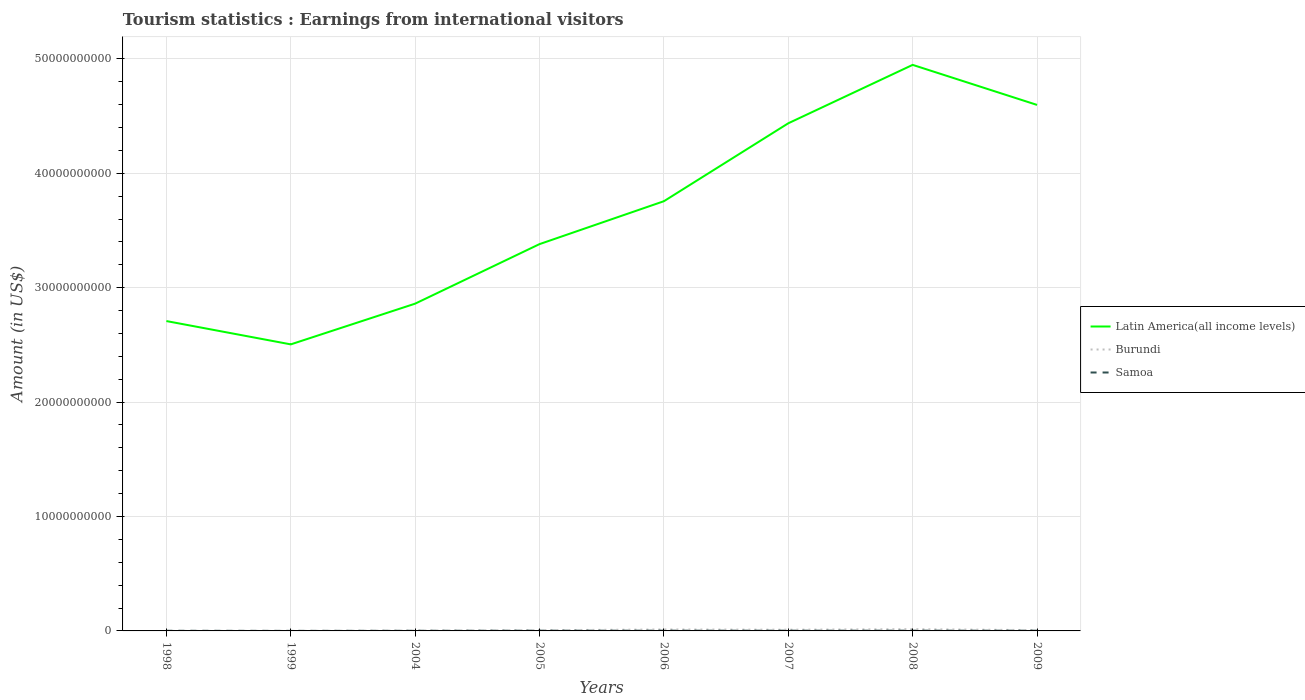Does the line corresponding to Burundi intersect with the line corresponding to Latin America(all income levels)?
Keep it short and to the point. No. Is the number of lines equal to the number of legend labels?
Give a very brief answer. Yes. Across all years, what is the maximum earnings from international visitors in Latin America(all income levels)?
Provide a succinct answer. 2.50e+1. In which year was the earnings from international visitors in Samoa maximum?
Your answer should be very brief. 1999. What is the total earnings from international visitors in Burundi in the graph?
Keep it short and to the point. -3.30e+07. What is the difference between the highest and the second highest earnings from international visitors in Burundi?
Offer a terse response. 1.49e+08. What is the difference between two consecutive major ticks on the Y-axis?
Your response must be concise. 1.00e+1. Are the values on the major ticks of Y-axis written in scientific E-notation?
Provide a short and direct response. No. What is the title of the graph?
Your response must be concise. Tourism statistics : Earnings from international visitors. Does "Uruguay" appear as one of the legend labels in the graph?
Offer a terse response. No. What is the label or title of the Y-axis?
Offer a terse response. Amount (in US$). What is the Amount (in US$) in Latin America(all income levels) in 1998?
Keep it short and to the point. 2.71e+1. What is the Amount (in US$) in Samoa in 1998?
Offer a terse response. 1.20e+07. What is the Amount (in US$) in Latin America(all income levels) in 1999?
Offer a very short reply. 2.50e+1. What is the Amount (in US$) in Samoa in 1999?
Your answer should be very brief. 4.40e+06. What is the Amount (in US$) in Latin America(all income levels) in 2004?
Your answer should be compact. 2.86e+1. What is the Amount (in US$) in Burundi in 2004?
Your response must be concise. 2.90e+07. What is the Amount (in US$) of Samoa in 2004?
Ensure brevity in your answer.  1.20e+07. What is the Amount (in US$) of Latin America(all income levels) in 2005?
Keep it short and to the point. 3.38e+1. What is the Amount (in US$) in Burundi in 2005?
Your answer should be very brief. 6.20e+07. What is the Amount (in US$) in Samoa in 2005?
Your answer should be compact. 2.03e+07. What is the Amount (in US$) in Latin America(all income levels) in 2006?
Your answer should be compact. 3.76e+1. What is the Amount (in US$) of Burundi in 2006?
Offer a terse response. 1.26e+08. What is the Amount (in US$) in Samoa in 2006?
Offer a very short reply. 2.12e+07. What is the Amount (in US$) of Latin America(all income levels) in 2007?
Your response must be concise. 4.44e+1. What is the Amount (in US$) of Burundi in 2007?
Provide a succinct answer. 1.06e+08. What is the Amount (in US$) in Samoa in 2007?
Keep it short and to the point. 1.98e+07. What is the Amount (in US$) of Latin America(all income levels) in 2008?
Keep it short and to the point. 4.95e+1. What is the Amount (in US$) of Burundi in 2008?
Your response must be concise. 1.51e+08. What is the Amount (in US$) of Samoa in 2008?
Your answer should be very brief. 2.16e+07. What is the Amount (in US$) of Latin America(all income levels) in 2009?
Keep it short and to the point. 4.60e+1. What is the Amount (in US$) in Burundi in 2009?
Your answer should be very brief. 7.10e+07. Across all years, what is the maximum Amount (in US$) in Latin America(all income levels)?
Your answer should be compact. 4.95e+1. Across all years, what is the maximum Amount (in US$) of Burundi?
Give a very brief answer. 1.51e+08. Across all years, what is the maximum Amount (in US$) of Samoa?
Your answer should be compact. 2.16e+07. Across all years, what is the minimum Amount (in US$) in Latin America(all income levels)?
Your answer should be very brief. 2.50e+1. Across all years, what is the minimum Amount (in US$) in Samoa?
Make the answer very short. 4.40e+06. What is the total Amount (in US$) of Latin America(all income levels) in the graph?
Your answer should be compact. 2.92e+11. What is the total Amount (in US$) in Burundi in the graph?
Keep it short and to the point. 5.50e+08. What is the total Amount (in US$) in Samoa in the graph?
Keep it short and to the point. 1.31e+08. What is the difference between the Amount (in US$) in Latin America(all income levels) in 1998 and that in 1999?
Offer a terse response. 2.04e+09. What is the difference between the Amount (in US$) of Samoa in 1998 and that in 1999?
Make the answer very short. 7.60e+06. What is the difference between the Amount (in US$) in Latin America(all income levels) in 1998 and that in 2004?
Provide a succinct answer. -1.52e+09. What is the difference between the Amount (in US$) of Burundi in 1998 and that in 2004?
Make the answer very short. -2.60e+07. What is the difference between the Amount (in US$) in Latin America(all income levels) in 1998 and that in 2005?
Your answer should be very brief. -6.73e+09. What is the difference between the Amount (in US$) in Burundi in 1998 and that in 2005?
Your answer should be compact. -5.90e+07. What is the difference between the Amount (in US$) in Samoa in 1998 and that in 2005?
Your answer should be very brief. -8.30e+06. What is the difference between the Amount (in US$) of Latin America(all income levels) in 1998 and that in 2006?
Give a very brief answer. -1.05e+1. What is the difference between the Amount (in US$) of Burundi in 1998 and that in 2006?
Provide a succinct answer. -1.23e+08. What is the difference between the Amount (in US$) of Samoa in 1998 and that in 2006?
Your response must be concise. -9.20e+06. What is the difference between the Amount (in US$) of Latin America(all income levels) in 1998 and that in 2007?
Your answer should be compact. -1.73e+1. What is the difference between the Amount (in US$) of Burundi in 1998 and that in 2007?
Your response must be concise. -1.03e+08. What is the difference between the Amount (in US$) of Samoa in 1998 and that in 2007?
Keep it short and to the point. -7.80e+06. What is the difference between the Amount (in US$) of Latin America(all income levels) in 1998 and that in 2008?
Make the answer very short. -2.24e+1. What is the difference between the Amount (in US$) in Burundi in 1998 and that in 2008?
Provide a short and direct response. -1.48e+08. What is the difference between the Amount (in US$) in Samoa in 1998 and that in 2008?
Your response must be concise. -9.60e+06. What is the difference between the Amount (in US$) of Latin America(all income levels) in 1998 and that in 2009?
Provide a short and direct response. -1.89e+1. What is the difference between the Amount (in US$) in Burundi in 1998 and that in 2009?
Your answer should be compact. -6.80e+07. What is the difference between the Amount (in US$) in Samoa in 1998 and that in 2009?
Make the answer very short. -8.00e+06. What is the difference between the Amount (in US$) of Latin America(all income levels) in 1999 and that in 2004?
Your response must be concise. -3.56e+09. What is the difference between the Amount (in US$) of Burundi in 1999 and that in 2004?
Your answer should be very brief. -2.70e+07. What is the difference between the Amount (in US$) in Samoa in 1999 and that in 2004?
Your response must be concise. -7.60e+06. What is the difference between the Amount (in US$) of Latin America(all income levels) in 1999 and that in 2005?
Ensure brevity in your answer.  -8.76e+09. What is the difference between the Amount (in US$) of Burundi in 1999 and that in 2005?
Your answer should be very brief. -6.00e+07. What is the difference between the Amount (in US$) in Samoa in 1999 and that in 2005?
Give a very brief answer. -1.59e+07. What is the difference between the Amount (in US$) in Latin America(all income levels) in 1999 and that in 2006?
Your response must be concise. -1.25e+1. What is the difference between the Amount (in US$) of Burundi in 1999 and that in 2006?
Provide a short and direct response. -1.24e+08. What is the difference between the Amount (in US$) in Samoa in 1999 and that in 2006?
Offer a very short reply. -1.68e+07. What is the difference between the Amount (in US$) in Latin America(all income levels) in 1999 and that in 2007?
Make the answer very short. -1.93e+1. What is the difference between the Amount (in US$) of Burundi in 1999 and that in 2007?
Ensure brevity in your answer.  -1.04e+08. What is the difference between the Amount (in US$) of Samoa in 1999 and that in 2007?
Keep it short and to the point. -1.54e+07. What is the difference between the Amount (in US$) in Latin America(all income levels) in 1999 and that in 2008?
Make the answer very short. -2.44e+1. What is the difference between the Amount (in US$) of Burundi in 1999 and that in 2008?
Offer a very short reply. -1.49e+08. What is the difference between the Amount (in US$) in Samoa in 1999 and that in 2008?
Give a very brief answer. -1.72e+07. What is the difference between the Amount (in US$) of Latin America(all income levels) in 1999 and that in 2009?
Keep it short and to the point. -2.09e+1. What is the difference between the Amount (in US$) in Burundi in 1999 and that in 2009?
Your answer should be compact. -6.90e+07. What is the difference between the Amount (in US$) in Samoa in 1999 and that in 2009?
Your response must be concise. -1.56e+07. What is the difference between the Amount (in US$) in Latin America(all income levels) in 2004 and that in 2005?
Make the answer very short. -5.20e+09. What is the difference between the Amount (in US$) of Burundi in 2004 and that in 2005?
Your response must be concise. -3.30e+07. What is the difference between the Amount (in US$) of Samoa in 2004 and that in 2005?
Keep it short and to the point. -8.30e+06. What is the difference between the Amount (in US$) in Latin America(all income levels) in 2004 and that in 2006?
Offer a very short reply. -8.95e+09. What is the difference between the Amount (in US$) in Burundi in 2004 and that in 2006?
Ensure brevity in your answer.  -9.70e+07. What is the difference between the Amount (in US$) of Samoa in 2004 and that in 2006?
Offer a very short reply. -9.20e+06. What is the difference between the Amount (in US$) in Latin America(all income levels) in 2004 and that in 2007?
Give a very brief answer. -1.58e+1. What is the difference between the Amount (in US$) of Burundi in 2004 and that in 2007?
Your response must be concise. -7.70e+07. What is the difference between the Amount (in US$) of Samoa in 2004 and that in 2007?
Your answer should be compact. -7.80e+06. What is the difference between the Amount (in US$) of Latin America(all income levels) in 2004 and that in 2008?
Provide a short and direct response. -2.09e+1. What is the difference between the Amount (in US$) of Burundi in 2004 and that in 2008?
Provide a short and direct response. -1.22e+08. What is the difference between the Amount (in US$) in Samoa in 2004 and that in 2008?
Ensure brevity in your answer.  -9.60e+06. What is the difference between the Amount (in US$) in Latin America(all income levels) in 2004 and that in 2009?
Offer a very short reply. -1.74e+1. What is the difference between the Amount (in US$) of Burundi in 2004 and that in 2009?
Provide a succinct answer. -4.20e+07. What is the difference between the Amount (in US$) of Samoa in 2004 and that in 2009?
Your answer should be compact. -8.00e+06. What is the difference between the Amount (in US$) in Latin America(all income levels) in 2005 and that in 2006?
Provide a short and direct response. -3.75e+09. What is the difference between the Amount (in US$) of Burundi in 2005 and that in 2006?
Keep it short and to the point. -6.40e+07. What is the difference between the Amount (in US$) of Samoa in 2005 and that in 2006?
Give a very brief answer. -9.00e+05. What is the difference between the Amount (in US$) in Latin America(all income levels) in 2005 and that in 2007?
Make the answer very short. -1.06e+1. What is the difference between the Amount (in US$) in Burundi in 2005 and that in 2007?
Ensure brevity in your answer.  -4.40e+07. What is the difference between the Amount (in US$) in Latin America(all income levels) in 2005 and that in 2008?
Offer a very short reply. -1.57e+1. What is the difference between the Amount (in US$) of Burundi in 2005 and that in 2008?
Your answer should be very brief. -8.90e+07. What is the difference between the Amount (in US$) in Samoa in 2005 and that in 2008?
Keep it short and to the point. -1.30e+06. What is the difference between the Amount (in US$) of Latin America(all income levels) in 2005 and that in 2009?
Ensure brevity in your answer.  -1.22e+1. What is the difference between the Amount (in US$) in Burundi in 2005 and that in 2009?
Make the answer very short. -9.00e+06. What is the difference between the Amount (in US$) in Samoa in 2005 and that in 2009?
Provide a succinct answer. 3.00e+05. What is the difference between the Amount (in US$) in Latin America(all income levels) in 2006 and that in 2007?
Ensure brevity in your answer.  -6.81e+09. What is the difference between the Amount (in US$) of Samoa in 2006 and that in 2007?
Keep it short and to the point. 1.40e+06. What is the difference between the Amount (in US$) in Latin America(all income levels) in 2006 and that in 2008?
Your answer should be compact. -1.19e+1. What is the difference between the Amount (in US$) in Burundi in 2006 and that in 2008?
Your answer should be compact. -2.50e+07. What is the difference between the Amount (in US$) in Samoa in 2006 and that in 2008?
Offer a terse response. -4.00e+05. What is the difference between the Amount (in US$) of Latin America(all income levels) in 2006 and that in 2009?
Provide a succinct answer. -8.42e+09. What is the difference between the Amount (in US$) of Burundi in 2006 and that in 2009?
Offer a very short reply. 5.50e+07. What is the difference between the Amount (in US$) in Samoa in 2006 and that in 2009?
Ensure brevity in your answer.  1.20e+06. What is the difference between the Amount (in US$) in Latin America(all income levels) in 2007 and that in 2008?
Offer a very short reply. -5.10e+09. What is the difference between the Amount (in US$) in Burundi in 2007 and that in 2008?
Provide a succinct answer. -4.50e+07. What is the difference between the Amount (in US$) of Samoa in 2007 and that in 2008?
Give a very brief answer. -1.80e+06. What is the difference between the Amount (in US$) of Latin America(all income levels) in 2007 and that in 2009?
Offer a terse response. -1.60e+09. What is the difference between the Amount (in US$) in Burundi in 2007 and that in 2009?
Keep it short and to the point. 3.50e+07. What is the difference between the Amount (in US$) in Latin America(all income levels) in 2008 and that in 2009?
Make the answer very short. 3.50e+09. What is the difference between the Amount (in US$) of Burundi in 2008 and that in 2009?
Make the answer very short. 8.00e+07. What is the difference between the Amount (in US$) of Samoa in 2008 and that in 2009?
Offer a very short reply. 1.60e+06. What is the difference between the Amount (in US$) in Latin America(all income levels) in 1998 and the Amount (in US$) in Burundi in 1999?
Provide a succinct answer. 2.71e+1. What is the difference between the Amount (in US$) of Latin America(all income levels) in 1998 and the Amount (in US$) of Samoa in 1999?
Provide a succinct answer. 2.71e+1. What is the difference between the Amount (in US$) in Burundi in 1998 and the Amount (in US$) in Samoa in 1999?
Your answer should be compact. -1.40e+06. What is the difference between the Amount (in US$) of Latin America(all income levels) in 1998 and the Amount (in US$) of Burundi in 2004?
Keep it short and to the point. 2.71e+1. What is the difference between the Amount (in US$) in Latin America(all income levels) in 1998 and the Amount (in US$) in Samoa in 2004?
Provide a succinct answer. 2.71e+1. What is the difference between the Amount (in US$) of Burundi in 1998 and the Amount (in US$) of Samoa in 2004?
Offer a terse response. -9.00e+06. What is the difference between the Amount (in US$) of Latin America(all income levels) in 1998 and the Amount (in US$) of Burundi in 2005?
Your answer should be compact. 2.70e+1. What is the difference between the Amount (in US$) of Latin America(all income levels) in 1998 and the Amount (in US$) of Samoa in 2005?
Your answer should be compact. 2.71e+1. What is the difference between the Amount (in US$) of Burundi in 1998 and the Amount (in US$) of Samoa in 2005?
Offer a terse response. -1.73e+07. What is the difference between the Amount (in US$) in Latin America(all income levels) in 1998 and the Amount (in US$) in Burundi in 2006?
Your response must be concise. 2.70e+1. What is the difference between the Amount (in US$) of Latin America(all income levels) in 1998 and the Amount (in US$) of Samoa in 2006?
Provide a short and direct response. 2.71e+1. What is the difference between the Amount (in US$) in Burundi in 1998 and the Amount (in US$) in Samoa in 2006?
Offer a terse response. -1.82e+07. What is the difference between the Amount (in US$) in Latin America(all income levels) in 1998 and the Amount (in US$) in Burundi in 2007?
Offer a very short reply. 2.70e+1. What is the difference between the Amount (in US$) of Latin America(all income levels) in 1998 and the Amount (in US$) of Samoa in 2007?
Give a very brief answer. 2.71e+1. What is the difference between the Amount (in US$) of Burundi in 1998 and the Amount (in US$) of Samoa in 2007?
Your answer should be very brief. -1.68e+07. What is the difference between the Amount (in US$) in Latin America(all income levels) in 1998 and the Amount (in US$) in Burundi in 2008?
Keep it short and to the point. 2.69e+1. What is the difference between the Amount (in US$) of Latin America(all income levels) in 1998 and the Amount (in US$) of Samoa in 2008?
Keep it short and to the point. 2.71e+1. What is the difference between the Amount (in US$) in Burundi in 1998 and the Amount (in US$) in Samoa in 2008?
Your answer should be very brief. -1.86e+07. What is the difference between the Amount (in US$) in Latin America(all income levels) in 1998 and the Amount (in US$) in Burundi in 2009?
Offer a very short reply. 2.70e+1. What is the difference between the Amount (in US$) of Latin America(all income levels) in 1998 and the Amount (in US$) of Samoa in 2009?
Provide a short and direct response. 2.71e+1. What is the difference between the Amount (in US$) in Burundi in 1998 and the Amount (in US$) in Samoa in 2009?
Offer a terse response. -1.70e+07. What is the difference between the Amount (in US$) of Latin America(all income levels) in 1999 and the Amount (in US$) of Burundi in 2004?
Ensure brevity in your answer.  2.50e+1. What is the difference between the Amount (in US$) in Latin America(all income levels) in 1999 and the Amount (in US$) in Samoa in 2004?
Ensure brevity in your answer.  2.50e+1. What is the difference between the Amount (in US$) in Burundi in 1999 and the Amount (in US$) in Samoa in 2004?
Your response must be concise. -1.00e+07. What is the difference between the Amount (in US$) in Latin America(all income levels) in 1999 and the Amount (in US$) in Burundi in 2005?
Offer a very short reply. 2.50e+1. What is the difference between the Amount (in US$) in Latin America(all income levels) in 1999 and the Amount (in US$) in Samoa in 2005?
Your answer should be very brief. 2.50e+1. What is the difference between the Amount (in US$) of Burundi in 1999 and the Amount (in US$) of Samoa in 2005?
Provide a succinct answer. -1.83e+07. What is the difference between the Amount (in US$) of Latin America(all income levels) in 1999 and the Amount (in US$) of Burundi in 2006?
Offer a very short reply. 2.49e+1. What is the difference between the Amount (in US$) of Latin America(all income levels) in 1999 and the Amount (in US$) of Samoa in 2006?
Ensure brevity in your answer.  2.50e+1. What is the difference between the Amount (in US$) in Burundi in 1999 and the Amount (in US$) in Samoa in 2006?
Your answer should be compact. -1.92e+07. What is the difference between the Amount (in US$) of Latin America(all income levels) in 1999 and the Amount (in US$) of Burundi in 2007?
Provide a short and direct response. 2.49e+1. What is the difference between the Amount (in US$) in Latin America(all income levels) in 1999 and the Amount (in US$) in Samoa in 2007?
Ensure brevity in your answer.  2.50e+1. What is the difference between the Amount (in US$) in Burundi in 1999 and the Amount (in US$) in Samoa in 2007?
Offer a very short reply. -1.78e+07. What is the difference between the Amount (in US$) in Latin America(all income levels) in 1999 and the Amount (in US$) in Burundi in 2008?
Ensure brevity in your answer.  2.49e+1. What is the difference between the Amount (in US$) in Latin America(all income levels) in 1999 and the Amount (in US$) in Samoa in 2008?
Offer a terse response. 2.50e+1. What is the difference between the Amount (in US$) in Burundi in 1999 and the Amount (in US$) in Samoa in 2008?
Your response must be concise. -1.96e+07. What is the difference between the Amount (in US$) of Latin America(all income levels) in 1999 and the Amount (in US$) of Burundi in 2009?
Ensure brevity in your answer.  2.50e+1. What is the difference between the Amount (in US$) in Latin America(all income levels) in 1999 and the Amount (in US$) in Samoa in 2009?
Offer a very short reply. 2.50e+1. What is the difference between the Amount (in US$) of Burundi in 1999 and the Amount (in US$) of Samoa in 2009?
Provide a short and direct response. -1.80e+07. What is the difference between the Amount (in US$) in Latin America(all income levels) in 2004 and the Amount (in US$) in Burundi in 2005?
Offer a terse response. 2.85e+1. What is the difference between the Amount (in US$) in Latin America(all income levels) in 2004 and the Amount (in US$) in Samoa in 2005?
Make the answer very short. 2.86e+1. What is the difference between the Amount (in US$) in Burundi in 2004 and the Amount (in US$) in Samoa in 2005?
Offer a very short reply. 8.70e+06. What is the difference between the Amount (in US$) of Latin America(all income levels) in 2004 and the Amount (in US$) of Burundi in 2006?
Make the answer very short. 2.85e+1. What is the difference between the Amount (in US$) in Latin America(all income levels) in 2004 and the Amount (in US$) in Samoa in 2006?
Your response must be concise. 2.86e+1. What is the difference between the Amount (in US$) in Burundi in 2004 and the Amount (in US$) in Samoa in 2006?
Your response must be concise. 7.80e+06. What is the difference between the Amount (in US$) of Latin America(all income levels) in 2004 and the Amount (in US$) of Burundi in 2007?
Keep it short and to the point. 2.85e+1. What is the difference between the Amount (in US$) of Latin America(all income levels) in 2004 and the Amount (in US$) of Samoa in 2007?
Ensure brevity in your answer.  2.86e+1. What is the difference between the Amount (in US$) of Burundi in 2004 and the Amount (in US$) of Samoa in 2007?
Keep it short and to the point. 9.20e+06. What is the difference between the Amount (in US$) of Latin America(all income levels) in 2004 and the Amount (in US$) of Burundi in 2008?
Your response must be concise. 2.85e+1. What is the difference between the Amount (in US$) in Latin America(all income levels) in 2004 and the Amount (in US$) in Samoa in 2008?
Offer a very short reply. 2.86e+1. What is the difference between the Amount (in US$) in Burundi in 2004 and the Amount (in US$) in Samoa in 2008?
Provide a short and direct response. 7.40e+06. What is the difference between the Amount (in US$) of Latin America(all income levels) in 2004 and the Amount (in US$) of Burundi in 2009?
Offer a very short reply. 2.85e+1. What is the difference between the Amount (in US$) of Latin America(all income levels) in 2004 and the Amount (in US$) of Samoa in 2009?
Give a very brief answer. 2.86e+1. What is the difference between the Amount (in US$) in Burundi in 2004 and the Amount (in US$) in Samoa in 2009?
Your answer should be very brief. 9.00e+06. What is the difference between the Amount (in US$) in Latin America(all income levels) in 2005 and the Amount (in US$) in Burundi in 2006?
Give a very brief answer. 3.37e+1. What is the difference between the Amount (in US$) of Latin America(all income levels) in 2005 and the Amount (in US$) of Samoa in 2006?
Offer a terse response. 3.38e+1. What is the difference between the Amount (in US$) of Burundi in 2005 and the Amount (in US$) of Samoa in 2006?
Your answer should be very brief. 4.08e+07. What is the difference between the Amount (in US$) in Latin America(all income levels) in 2005 and the Amount (in US$) in Burundi in 2007?
Ensure brevity in your answer.  3.37e+1. What is the difference between the Amount (in US$) in Latin America(all income levels) in 2005 and the Amount (in US$) in Samoa in 2007?
Your answer should be compact. 3.38e+1. What is the difference between the Amount (in US$) in Burundi in 2005 and the Amount (in US$) in Samoa in 2007?
Your answer should be compact. 4.22e+07. What is the difference between the Amount (in US$) in Latin America(all income levels) in 2005 and the Amount (in US$) in Burundi in 2008?
Keep it short and to the point. 3.37e+1. What is the difference between the Amount (in US$) of Latin America(all income levels) in 2005 and the Amount (in US$) of Samoa in 2008?
Offer a terse response. 3.38e+1. What is the difference between the Amount (in US$) of Burundi in 2005 and the Amount (in US$) of Samoa in 2008?
Provide a succinct answer. 4.04e+07. What is the difference between the Amount (in US$) in Latin America(all income levels) in 2005 and the Amount (in US$) in Burundi in 2009?
Provide a succinct answer. 3.37e+1. What is the difference between the Amount (in US$) of Latin America(all income levels) in 2005 and the Amount (in US$) of Samoa in 2009?
Your response must be concise. 3.38e+1. What is the difference between the Amount (in US$) of Burundi in 2005 and the Amount (in US$) of Samoa in 2009?
Your answer should be compact. 4.20e+07. What is the difference between the Amount (in US$) in Latin America(all income levels) in 2006 and the Amount (in US$) in Burundi in 2007?
Ensure brevity in your answer.  3.75e+1. What is the difference between the Amount (in US$) of Latin America(all income levels) in 2006 and the Amount (in US$) of Samoa in 2007?
Give a very brief answer. 3.75e+1. What is the difference between the Amount (in US$) of Burundi in 2006 and the Amount (in US$) of Samoa in 2007?
Offer a very short reply. 1.06e+08. What is the difference between the Amount (in US$) of Latin America(all income levels) in 2006 and the Amount (in US$) of Burundi in 2008?
Make the answer very short. 3.74e+1. What is the difference between the Amount (in US$) of Latin America(all income levels) in 2006 and the Amount (in US$) of Samoa in 2008?
Offer a terse response. 3.75e+1. What is the difference between the Amount (in US$) in Burundi in 2006 and the Amount (in US$) in Samoa in 2008?
Ensure brevity in your answer.  1.04e+08. What is the difference between the Amount (in US$) of Latin America(all income levels) in 2006 and the Amount (in US$) of Burundi in 2009?
Make the answer very short. 3.75e+1. What is the difference between the Amount (in US$) in Latin America(all income levels) in 2006 and the Amount (in US$) in Samoa in 2009?
Offer a very short reply. 3.75e+1. What is the difference between the Amount (in US$) of Burundi in 2006 and the Amount (in US$) of Samoa in 2009?
Your answer should be very brief. 1.06e+08. What is the difference between the Amount (in US$) in Latin America(all income levels) in 2007 and the Amount (in US$) in Burundi in 2008?
Your answer should be very brief. 4.42e+1. What is the difference between the Amount (in US$) in Latin America(all income levels) in 2007 and the Amount (in US$) in Samoa in 2008?
Your answer should be compact. 4.43e+1. What is the difference between the Amount (in US$) in Burundi in 2007 and the Amount (in US$) in Samoa in 2008?
Offer a terse response. 8.44e+07. What is the difference between the Amount (in US$) in Latin America(all income levels) in 2007 and the Amount (in US$) in Burundi in 2009?
Offer a very short reply. 4.43e+1. What is the difference between the Amount (in US$) of Latin America(all income levels) in 2007 and the Amount (in US$) of Samoa in 2009?
Your response must be concise. 4.44e+1. What is the difference between the Amount (in US$) in Burundi in 2007 and the Amount (in US$) in Samoa in 2009?
Provide a succinct answer. 8.60e+07. What is the difference between the Amount (in US$) in Latin America(all income levels) in 2008 and the Amount (in US$) in Burundi in 2009?
Give a very brief answer. 4.94e+1. What is the difference between the Amount (in US$) of Latin America(all income levels) in 2008 and the Amount (in US$) of Samoa in 2009?
Provide a short and direct response. 4.95e+1. What is the difference between the Amount (in US$) of Burundi in 2008 and the Amount (in US$) of Samoa in 2009?
Your answer should be compact. 1.31e+08. What is the average Amount (in US$) of Latin America(all income levels) per year?
Give a very brief answer. 3.65e+1. What is the average Amount (in US$) in Burundi per year?
Offer a very short reply. 6.88e+07. What is the average Amount (in US$) of Samoa per year?
Give a very brief answer. 1.64e+07. In the year 1998, what is the difference between the Amount (in US$) in Latin America(all income levels) and Amount (in US$) in Burundi?
Your answer should be very brief. 2.71e+1. In the year 1998, what is the difference between the Amount (in US$) of Latin America(all income levels) and Amount (in US$) of Samoa?
Ensure brevity in your answer.  2.71e+1. In the year 1998, what is the difference between the Amount (in US$) of Burundi and Amount (in US$) of Samoa?
Your response must be concise. -9.00e+06. In the year 1999, what is the difference between the Amount (in US$) of Latin America(all income levels) and Amount (in US$) of Burundi?
Ensure brevity in your answer.  2.50e+1. In the year 1999, what is the difference between the Amount (in US$) of Latin America(all income levels) and Amount (in US$) of Samoa?
Your answer should be very brief. 2.50e+1. In the year 1999, what is the difference between the Amount (in US$) of Burundi and Amount (in US$) of Samoa?
Offer a very short reply. -2.40e+06. In the year 2004, what is the difference between the Amount (in US$) of Latin America(all income levels) and Amount (in US$) of Burundi?
Ensure brevity in your answer.  2.86e+1. In the year 2004, what is the difference between the Amount (in US$) of Latin America(all income levels) and Amount (in US$) of Samoa?
Provide a short and direct response. 2.86e+1. In the year 2004, what is the difference between the Amount (in US$) in Burundi and Amount (in US$) in Samoa?
Provide a short and direct response. 1.70e+07. In the year 2005, what is the difference between the Amount (in US$) of Latin America(all income levels) and Amount (in US$) of Burundi?
Your answer should be very brief. 3.37e+1. In the year 2005, what is the difference between the Amount (in US$) of Latin America(all income levels) and Amount (in US$) of Samoa?
Provide a succinct answer. 3.38e+1. In the year 2005, what is the difference between the Amount (in US$) of Burundi and Amount (in US$) of Samoa?
Keep it short and to the point. 4.17e+07. In the year 2006, what is the difference between the Amount (in US$) in Latin America(all income levels) and Amount (in US$) in Burundi?
Give a very brief answer. 3.74e+1. In the year 2006, what is the difference between the Amount (in US$) in Latin America(all income levels) and Amount (in US$) in Samoa?
Offer a terse response. 3.75e+1. In the year 2006, what is the difference between the Amount (in US$) of Burundi and Amount (in US$) of Samoa?
Provide a succinct answer. 1.05e+08. In the year 2007, what is the difference between the Amount (in US$) of Latin America(all income levels) and Amount (in US$) of Burundi?
Keep it short and to the point. 4.43e+1. In the year 2007, what is the difference between the Amount (in US$) in Latin America(all income levels) and Amount (in US$) in Samoa?
Ensure brevity in your answer.  4.44e+1. In the year 2007, what is the difference between the Amount (in US$) in Burundi and Amount (in US$) in Samoa?
Provide a short and direct response. 8.62e+07. In the year 2008, what is the difference between the Amount (in US$) of Latin America(all income levels) and Amount (in US$) of Burundi?
Your answer should be compact. 4.93e+1. In the year 2008, what is the difference between the Amount (in US$) in Latin America(all income levels) and Amount (in US$) in Samoa?
Ensure brevity in your answer.  4.95e+1. In the year 2008, what is the difference between the Amount (in US$) in Burundi and Amount (in US$) in Samoa?
Provide a succinct answer. 1.29e+08. In the year 2009, what is the difference between the Amount (in US$) in Latin America(all income levels) and Amount (in US$) in Burundi?
Your answer should be very brief. 4.59e+1. In the year 2009, what is the difference between the Amount (in US$) of Latin America(all income levels) and Amount (in US$) of Samoa?
Provide a short and direct response. 4.60e+1. In the year 2009, what is the difference between the Amount (in US$) of Burundi and Amount (in US$) of Samoa?
Ensure brevity in your answer.  5.10e+07. What is the ratio of the Amount (in US$) in Latin America(all income levels) in 1998 to that in 1999?
Ensure brevity in your answer.  1.08. What is the ratio of the Amount (in US$) in Burundi in 1998 to that in 1999?
Offer a terse response. 1.5. What is the ratio of the Amount (in US$) of Samoa in 1998 to that in 1999?
Ensure brevity in your answer.  2.73. What is the ratio of the Amount (in US$) of Latin America(all income levels) in 1998 to that in 2004?
Your answer should be compact. 0.95. What is the ratio of the Amount (in US$) in Burundi in 1998 to that in 2004?
Give a very brief answer. 0.1. What is the ratio of the Amount (in US$) of Samoa in 1998 to that in 2004?
Provide a succinct answer. 1. What is the ratio of the Amount (in US$) in Latin America(all income levels) in 1998 to that in 2005?
Ensure brevity in your answer.  0.8. What is the ratio of the Amount (in US$) of Burundi in 1998 to that in 2005?
Offer a terse response. 0.05. What is the ratio of the Amount (in US$) in Samoa in 1998 to that in 2005?
Your answer should be very brief. 0.59. What is the ratio of the Amount (in US$) in Latin America(all income levels) in 1998 to that in 2006?
Make the answer very short. 0.72. What is the ratio of the Amount (in US$) in Burundi in 1998 to that in 2006?
Provide a short and direct response. 0.02. What is the ratio of the Amount (in US$) of Samoa in 1998 to that in 2006?
Offer a terse response. 0.57. What is the ratio of the Amount (in US$) in Latin America(all income levels) in 1998 to that in 2007?
Offer a very short reply. 0.61. What is the ratio of the Amount (in US$) of Burundi in 1998 to that in 2007?
Your answer should be compact. 0.03. What is the ratio of the Amount (in US$) in Samoa in 1998 to that in 2007?
Keep it short and to the point. 0.61. What is the ratio of the Amount (in US$) of Latin America(all income levels) in 1998 to that in 2008?
Offer a terse response. 0.55. What is the ratio of the Amount (in US$) of Burundi in 1998 to that in 2008?
Ensure brevity in your answer.  0.02. What is the ratio of the Amount (in US$) of Samoa in 1998 to that in 2008?
Ensure brevity in your answer.  0.56. What is the ratio of the Amount (in US$) in Latin America(all income levels) in 1998 to that in 2009?
Provide a succinct answer. 0.59. What is the ratio of the Amount (in US$) in Burundi in 1998 to that in 2009?
Provide a short and direct response. 0.04. What is the ratio of the Amount (in US$) in Samoa in 1998 to that in 2009?
Ensure brevity in your answer.  0.6. What is the ratio of the Amount (in US$) of Latin America(all income levels) in 1999 to that in 2004?
Provide a short and direct response. 0.88. What is the ratio of the Amount (in US$) of Burundi in 1999 to that in 2004?
Make the answer very short. 0.07. What is the ratio of the Amount (in US$) of Samoa in 1999 to that in 2004?
Keep it short and to the point. 0.37. What is the ratio of the Amount (in US$) in Latin America(all income levels) in 1999 to that in 2005?
Your answer should be compact. 0.74. What is the ratio of the Amount (in US$) of Burundi in 1999 to that in 2005?
Give a very brief answer. 0.03. What is the ratio of the Amount (in US$) in Samoa in 1999 to that in 2005?
Provide a short and direct response. 0.22. What is the ratio of the Amount (in US$) of Latin America(all income levels) in 1999 to that in 2006?
Keep it short and to the point. 0.67. What is the ratio of the Amount (in US$) in Burundi in 1999 to that in 2006?
Your response must be concise. 0.02. What is the ratio of the Amount (in US$) of Samoa in 1999 to that in 2006?
Offer a terse response. 0.21. What is the ratio of the Amount (in US$) in Latin America(all income levels) in 1999 to that in 2007?
Ensure brevity in your answer.  0.56. What is the ratio of the Amount (in US$) of Burundi in 1999 to that in 2007?
Offer a very short reply. 0.02. What is the ratio of the Amount (in US$) in Samoa in 1999 to that in 2007?
Your response must be concise. 0.22. What is the ratio of the Amount (in US$) of Latin America(all income levels) in 1999 to that in 2008?
Make the answer very short. 0.51. What is the ratio of the Amount (in US$) of Burundi in 1999 to that in 2008?
Give a very brief answer. 0.01. What is the ratio of the Amount (in US$) in Samoa in 1999 to that in 2008?
Your response must be concise. 0.2. What is the ratio of the Amount (in US$) in Latin America(all income levels) in 1999 to that in 2009?
Your response must be concise. 0.54. What is the ratio of the Amount (in US$) of Burundi in 1999 to that in 2009?
Provide a short and direct response. 0.03. What is the ratio of the Amount (in US$) of Samoa in 1999 to that in 2009?
Provide a succinct answer. 0.22. What is the ratio of the Amount (in US$) of Latin America(all income levels) in 2004 to that in 2005?
Your answer should be compact. 0.85. What is the ratio of the Amount (in US$) in Burundi in 2004 to that in 2005?
Keep it short and to the point. 0.47. What is the ratio of the Amount (in US$) in Samoa in 2004 to that in 2005?
Make the answer very short. 0.59. What is the ratio of the Amount (in US$) of Latin America(all income levels) in 2004 to that in 2006?
Provide a short and direct response. 0.76. What is the ratio of the Amount (in US$) in Burundi in 2004 to that in 2006?
Offer a very short reply. 0.23. What is the ratio of the Amount (in US$) in Samoa in 2004 to that in 2006?
Give a very brief answer. 0.57. What is the ratio of the Amount (in US$) in Latin America(all income levels) in 2004 to that in 2007?
Offer a terse response. 0.64. What is the ratio of the Amount (in US$) in Burundi in 2004 to that in 2007?
Give a very brief answer. 0.27. What is the ratio of the Amount (in US$) of Samoa in 2004 to that in 2007?
Make the answer very short. 0.61. What is the ratio of the Amount (in US$) of Latin America(all income levels) in 2004 to that in 2008?
Give a very brief answer. 0.58. What is the ratio of the Amount (in US$) in Burundi in 2004 to that in 2008?
Your answer should be very brief. 0.19. What is the ratio of the Amount (in US$) of Samoa in 2004 to that in 2008?
Offer a very short reply. 0.56. What is the ratio of the Amount (in US$) in Latin America(all income levels) in 2004 to that in 2009?
Offer a very short reply. 0.62. What is the ratio of the Amount (in US$) in Burundi in 2004 to that in 2009?
Your answer should be very brief. 0.41. What is the ratio of the Amount (in US$) of Latin America(all income levels) in 2005 to that in 2006?
Provide a succinct answer. 0.9. What is the ratio of the Amount (in US$) in Burundi in 2005 to that in 2006?
Provide a short and direct response. 0.49. What is the ratio of the Amount (in US$) of Samoa in 2005 to that in 2006?
Give a very brief answer. 0.96. What is the ratio of the Amount (in US$) in Latin America(all income levels) in 2005 to that in 2007?
Make the answer very short. 0.76. What is the ratio of the Amount (in US$) of Burundi in 2005 to that in 2007?
Your answer should be compact. 0.58. What is the ratio of the Amount (in US$) of Samoa in 2005 to that in 2007?
Your response must be concise. 1.03. What is the ratio of the Amount (in US$) of Latin America(all income levels) in 2005 to that in 2008?
Offer a terse response. 0.68. What is the ratio of the Amount (in US$) of Burundi in 2005 to that in 2008?
Keep it short and to the point. 0.41. What is the ratio of the Amount (in US$) in Samoa in 2005 to that in 2008?
Offer a terse response. 0.94. What is the ratio of the Amount (in US$) in Latin America(all income levels) in 2005 to that in 2009?
Ensure brevity in your answer.  0.74. What is the ratio of the Amount (in US$) of Burundi in 2005 to that in 2009?
Give a very brief answer. 0.87. What is the ratio of the Amount (in US$) of Latin America(all income levels) in 2006 to that in 2007?
Provide a succinct answer. 0.85. What is the ratio of the Amount (in US$) of Burundi in 2006 to that in 2007?
Keep it short and to the point. 1.19. What is the ratio of the Amount (in US$) in Samoa in 2006 to that in 2007?
Offer a terse response. 1.07. What is the ratio of the Amount (in US$) of Latin America(all income levels) in 2006 to that in 2008?
Provide a short and direct response. 0.76. What is the ratio of the Amount (in US$) in Burundi in 2006 to that in 2008?
Offer a very short reply. 0.83. What is the ratio of the Amount (in US$) in Samoa in 2006 to that in 2008?
Your response must be concise. 0.98. What is the ratio of the Amount (in US$) in Latin America(all income levels) in 2006 to that in 2009?
Give a very brief answer. 0.82. What is the ratio of the Amount (in US$) in Burundi in 2006 to that in 2009?
Ensure brevity in your answer.  1.77. What is the ratio of the Amount (in US$) in Samoa in 2006 to that in 2009?
Give a very brief answer. 1.06. What is the ratio of the Amount (in US$) in Latin America(all income levels) in 2007 to that in 2008?
Give a very brief answer. 0.9. What is the ratio of the Amount (in US$) in Burundi in 2007 to that in 2008?
Give a very brief answer. 0.7. What is the ratio of the Amount (in US$) in Samoa in 2007 to that in 2008?
Provide a short and direct response. 0.92. What is the ratio of the Amount (in US$) of Latin America(all income levels) in 2007 to that in 2009?
Provide a succinct answer. 0.97. What is the ratio of the Amount (in US$) of Burundi in 2007 to that in 2009?
Your answer should be compact. 1.49. What is the ratio of the Amount (in US$) of Latin America(all income levels) in 2008 to that in 2009?
Your answer should be compact. 1.08. What is the ratio of the Amount (in US$) of Burundi in 2008 to that in 2009?
Your response must be concise. 2.13. What is the difference between the highest and the second highest Amount (in US$) in Latin America(all income levels)?
Ensure brevity in your answer.  3.50e+09. What is the difference between the highest and the second highest Amount (in US$) of Burundi?
Provide a short and direct response. 2.50e+07. What is the difference between the highest and the second highest Amount (in US$) of Samoa?
Offer a terse response. 4.00e+05. What is the difference between the highest and the lowest Amount (in US$) in Latin America(all income levels)?
Your answer should be compact. 2.44e+1. What is the difference between the highest and the lowest Amount (in US$) of Burundi?
Your response must be concise. 1.49e+08. What is the difference between the highest and the lowest Amount (in US$) of Samoa?
Your answer should be very brief. 1.72e+07. 